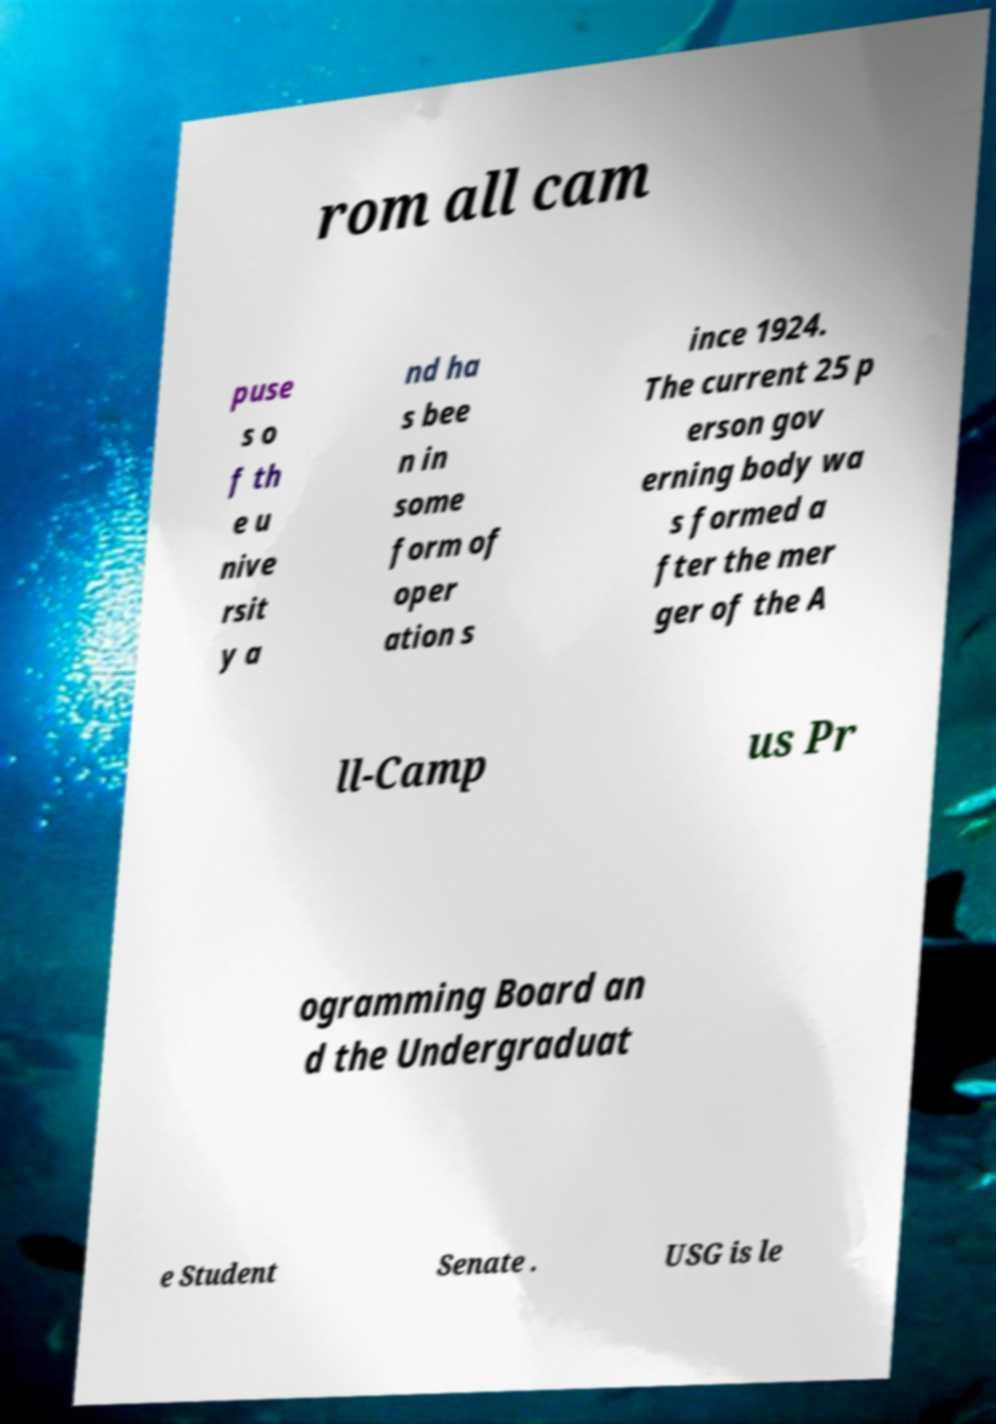What messages or text are displayed in this image? I need them in a readable, typed format. rom all cam puse s o f th e u nive rsit y a nd ha s bee n in some form of oper ation s ince 1924. The current 25 p erson gov erning body wa s formed a fter the mer ger of the A ll-Camp us Pr ogramming Board an d the Undergraduat e Student Senate . USG is le 